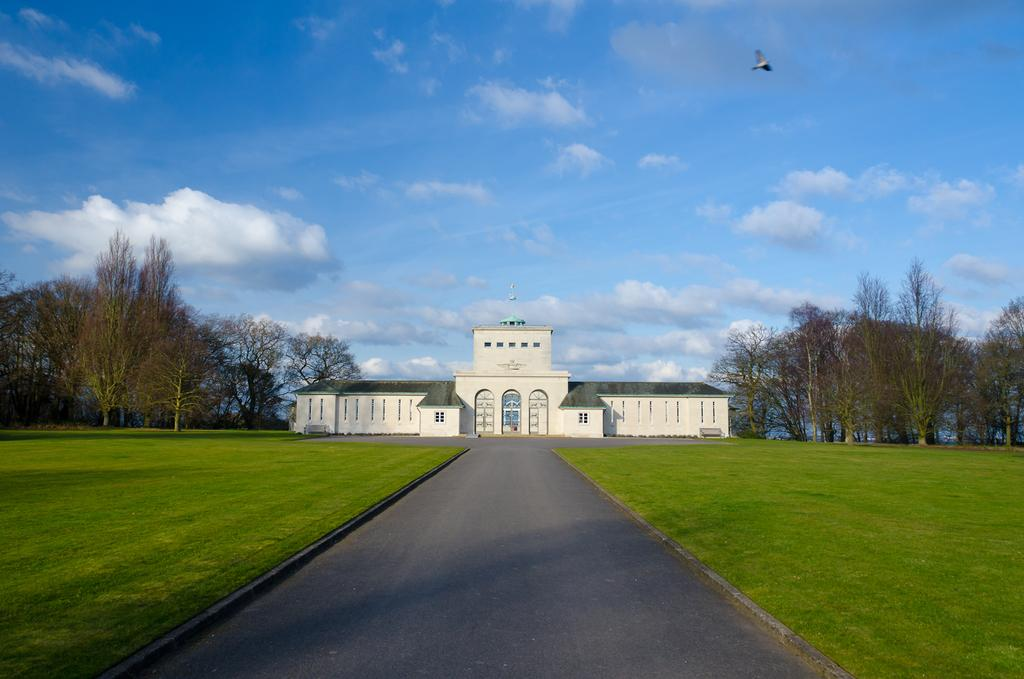What type of structure is present in the image? There is a building in the image. What can be seen on the wall of the building? There is text on the wall of the building. What type of vegetation is visible in the image? There are trees in the image. What is visible at the top of the image? The sky is visible at the top of the image. What is located at the bottom of the image? There is a road and grass visible at the bottom of the image. What type of credit can be seen on the wall of the building in the image? There is no credit visible on the wall of the building in the image. Is there a prison visible in the image? No, there is no prison present in the image. 